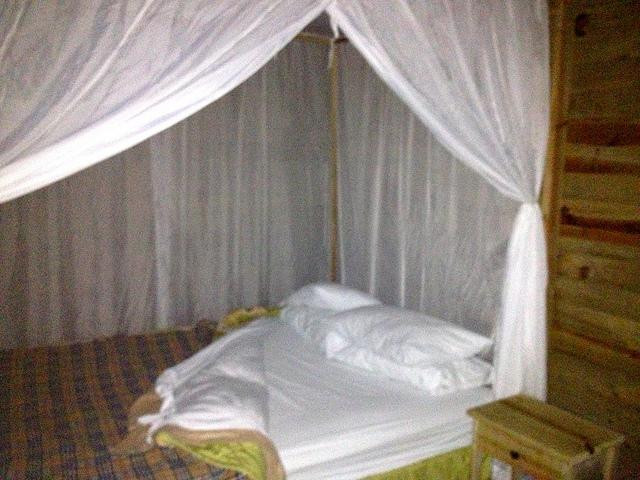What is the color of the pillows?
Keep it brief. White. Are there any objects on the nightstand?
Answer briefly. No. What room is this?
Be succinct. Bedroom. 